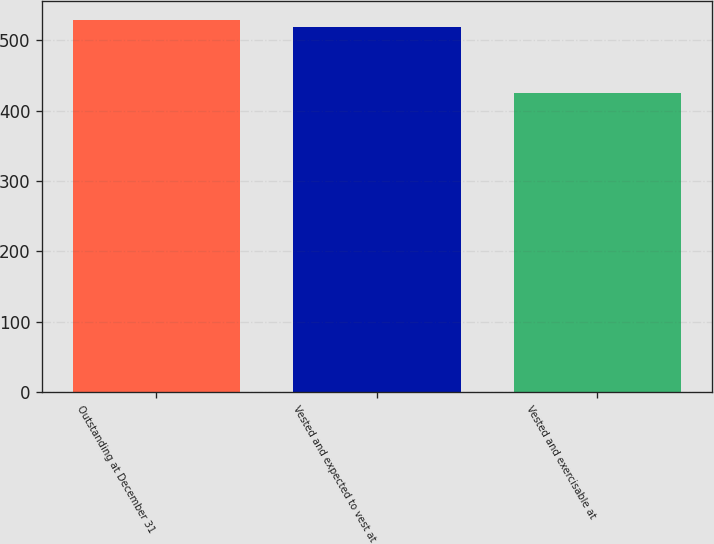<chart> <loc_0><loc_0><loc_500><loc_500><bar_chart><fcel>Outstanding at December 31<fcel>Vested and expected to vest at<fcel>Vested and exercisable at<nl><fcel>529.3<fcel>519<fcel>425<nl></chart> 